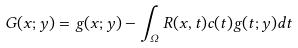<formula> <loc_0><loc_0><loc_500><loc_500>G ( x ; y ) = g ( x ; y ) - \int _ { \Omega } R ( x , t ) c ( t ) g ( t ; y ) d t</formula> 